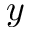<formula> <loc_0><loc_0><loc_500><loc_500>y</formula> 